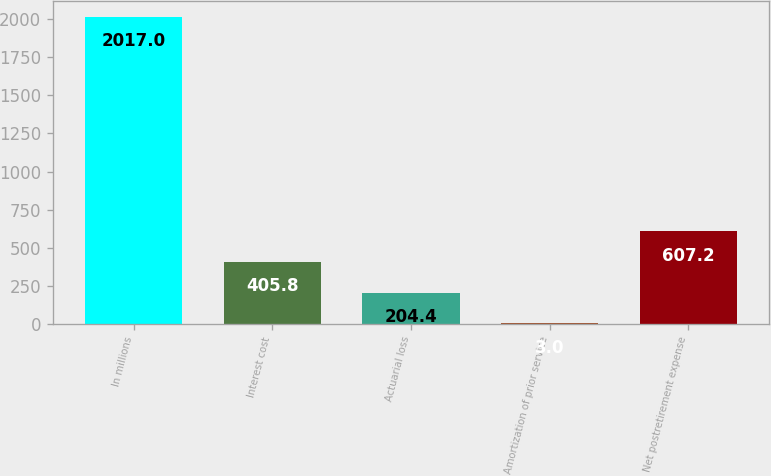<chart> <loc_0><loc_0><loc_500><loc_500><bar_chart><fcel>In millions<fcel>Interest cost<fcel>Actuarial loss<fcel>Amortization of prior service<fcel>Net postretirement expense<nl><fcel>2017<fcel>405.8<fcel>204.4<fcel>3<fcel>607.2<nl></chart> 